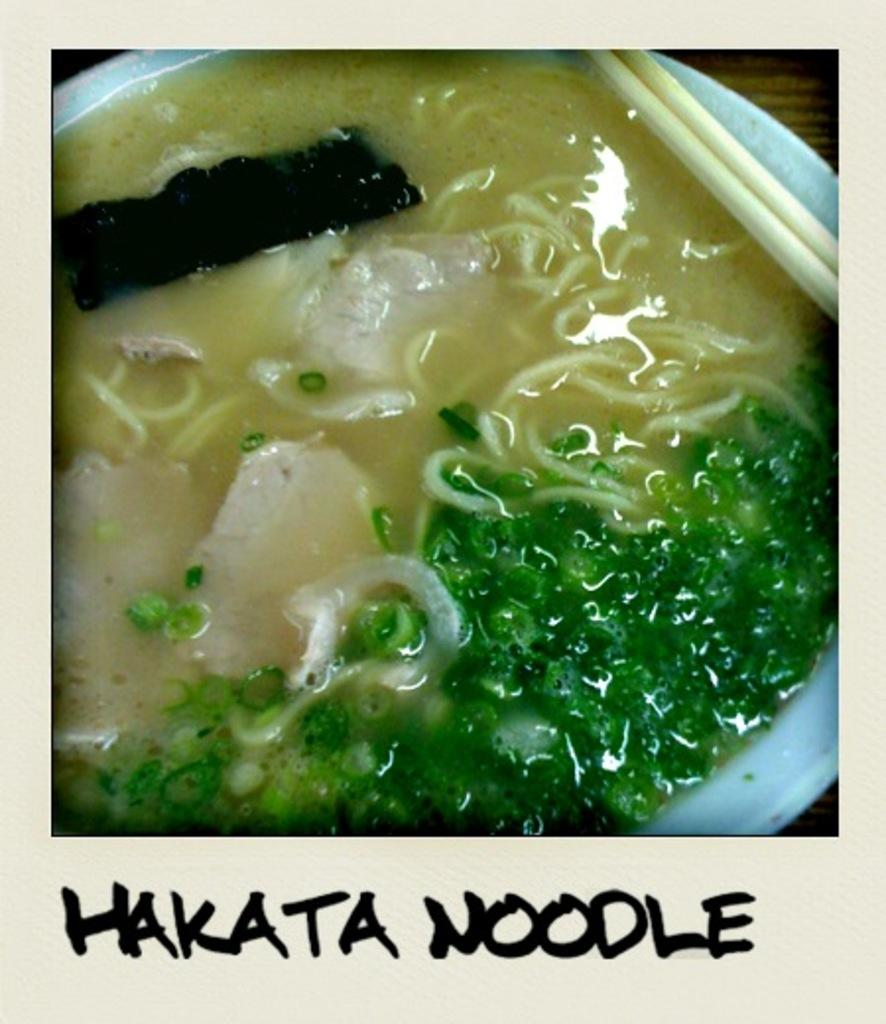What is present in the image related to eating? There is food and chopsticks in the image. How are the food and chopsticks arranged in the image? The food and chopsticks are in a plate. Where is the plate located in the image? The plate is placed on a table. Is there any text in the image? Yes, there is text at the bottom of the image. How does the food whistle in the image? The food does not whistle in the image; it is a still image with no sounds. 